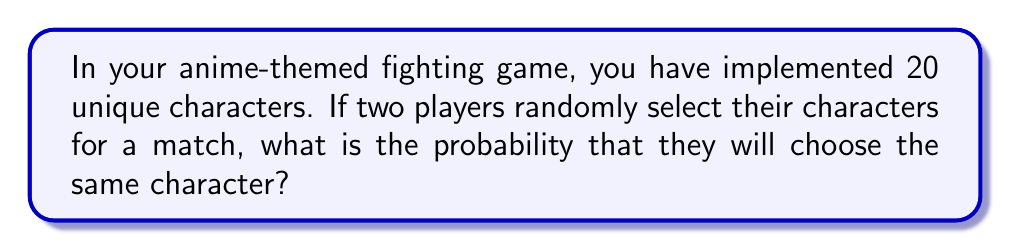Can you answer this question? Let's approach this step-by-step:

1) First, we need to understand what we're calculating. We want the probability of both players selecting the same character out of 20 possible characters.

2) The total number of possible outcomes when two players select characters is:
   $20 \times 20 = 400$ (first player has 20 choices, second player also has 20 choices)

3) Now, we need to count the favorable outcomes. There are 20 ways for both players to select the same character (they could both select character 1, or both select character 2, etc.)

4) The probability is calculated by dividing the number of favorable outcomes by the total number of possible outcomes:

   $$P(\text{same character}) = \frac{\text{favorable outcomes}}{\text{total outcomes}} = \frac{20}{400} = \frac{1}{20} = 0.05$$

5) This can also be expressed as a percentage: $0.05 \times 100\% = 5\%$

Therefore, there is a 5% chance that both players will randomly select the same character.
Answer: $\frac{1}{20}$ or 0.05 or 5% 